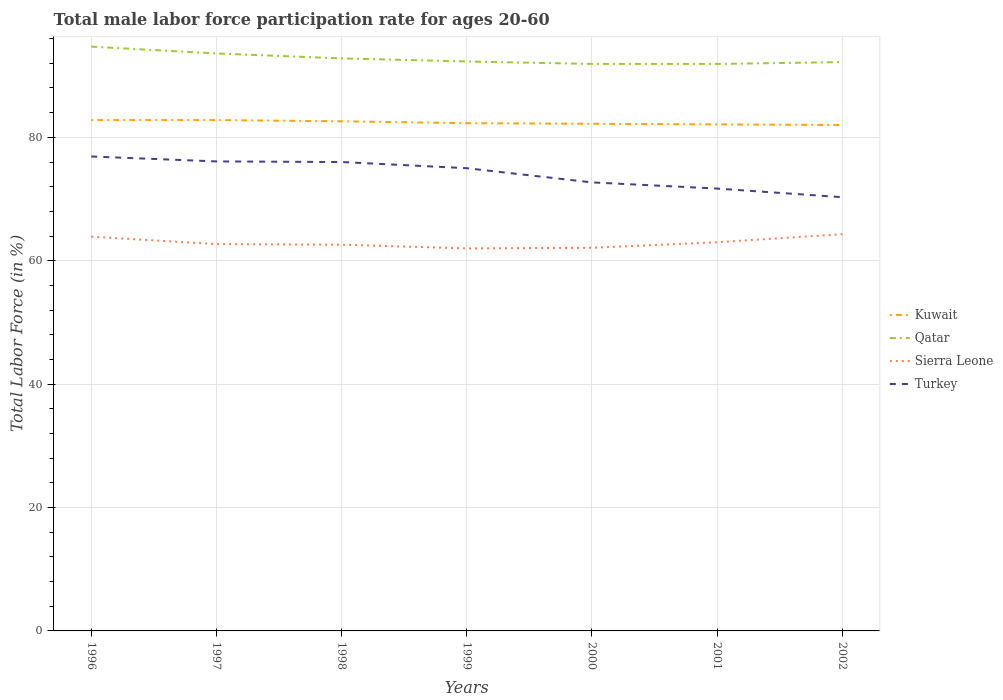How many different coloured lines are there?
Your answer should be compact. 4. Does the line corresponding to Sierra Leone intersect with the line corresponding to Turkey?
Provide a short and direct response. No. Across all years, what is the maximum male labor force participation rate in Turkey?
Your answer should be compact. 70.3. In which year was the male labor force participation rate in Qatar maximum?
Provide a short and direct response. 2000. What is the total male labor force participation rate in Turkey in the graph?
Keep it short and to the point. 4.4. What is the difference between the highest and the second highest male labor force participation rate in Sierra Leone?
Provide a short and direct response. 2.3. How many lines are there?
Your response must be concise. 4. Are the values on the major ticks of Y-axis written in scientific E-notation?
Provide a succinct answer. No. Does the graph contain any zero values?
Provide a short and direct response. No. Where does the legend appear in the graph?
Your answer should be very brief. Center right. How many legend labels are there?
Give a very brief answer. 4. What is the title of the graph?
Ensure brevity in your answer.  Total male labor force participation rate for ages 20-60. Does "Tajikistan" appear as one of the legend labels in the graph?
Your answer should be very brief. No. What is the label or title of the X-axis?
Your answer should be very brief. Years. What is the label or title of the Y-axis?
Provide a short and direct response. Total Labor Force (in %). What is the Total Labor Force (in %) in Kuwait in 1996?
Give a very brief answer. 82.8. What is the Total Labor Force (in %) in Qatar in 1996?
Make the answer very short. 94.7. What is the Total Labor Force (in %) of Sierra Leone in 1996?
Ensure brevity in your answer.  63.9. What is the Total Labor Force (in %) of Turkey in 1996?
Keep it short and to the point. 76.9. What is the Total Labor Force (in %) of Kuwait in 1997?
Ensure brevity in your answer.  82.8. What is the Total Labor Force (in %) of Qatar in 1997?
Keep it short and to the point. 93.6. What is the Total Labor Force (in %) of Sierra Leone in 1997?
Provide a short and direct response. 62.7. What is the Total Labor Force (in %) in Turkey in 1997?
Your answer should be compact. 76.1. What is the Total Labor Force (in %) in Kuwait in 1998?
Keep it short and to the point. 82.6. What is the Total Labor Force (in %) in Qatar in 1998?
Provide a succinct answer. 92.8. What is the Total Labor Force (in %) of Sierra Leone in 1998?
Your answer should be very brief. 62.6. What is the Total Labor Force (in %) in Kuwait in 1999?
Provide a short and direct response. 82.3. What is the Total Labor Force (in %) of Qatar in 1999?
Your answer should be very brief. 92.3. What is the Total Labor Force (in %) in Kuwait in 2000?
Your answer should be very brief. 82.2. What is the Total Labor Force (in %) of Qatar in 2000?
Offer a terse response. 91.9. What is the Total Labor Force (in %) in Sierra Leone in 2000?
Keep it short and to the point. 62.1. What is the Total Labor Force (in %) of Turkey in 2000?
Ensure brevity in your answer.  72.7. What is the Total Labor Force (in %) in Kuwait in 2001?
Ensure brevity in your answer.  82.1. What is the Total Labor Force (in %) of Qatar in 2001?
Give a very brief answer. 91.9. What is the Total Labor Force (in %) in Turkey in 2001?
Provide a short and direct response. 71.7. What is the Total Labor Force (in %) of Qatar in 2002?
Offer a terse response. 92.2. What is the Total Labor Force (in %) in Sierra Leone in 2002?
Give a very brief answer. 64.3. What is the Total Labor Force (in %) in Turkey in 2002?
Your answer should be compact. 70.3. Across all years, what is the maximum Total Labor Force (in %) of Kuwait?
Give a very brief answer. 82.8. Across all years, what is the maximum Total Labor Force (in %) in Qatar?
Offer a terse response. 94.7. Across all years, what is the maximum Total Labor Force (in %) in Sierra Leone?
Your answer should be very brief. 64.3. Across all years, what is the maximum Total Labor Force (in %) in Turkey?
Offer a very short reply. 76.9. Across all years, what is the minimum Total Labor Force (in %) in Qatar?
Make the answer very short. 91.9. Across all years, what is the minimum Total Labor Force (in %) in Sierra Leone?
Provide a succinct answer. 62. Across all years, what is the minimum Total Labor Force (in %) of Turkey?
Offer a very short reply. 70.3. What is the total Total Labor Force (in %) in Kuwait in the graph?
Give a very brief answer. 576.8. What is the total Total Labor Force (in %) in Qatar in the graph?
Provide a succinct answer. 649.4. What is the total Total Labor Force (in %) in Sierra Leone in the graph?
Ensure brevity in your answer.  440.6. What is the total Total Labor Force (in %) in Turkey in the graph?
Your answer should be very brief. 518.7. What is the difference between the Total Labor Force (in %) of Kuwait in 1996 and that in 1997?
Your answer should be compact. 0. What is the difference between the Total Labor Force (in %) in Kuwait in 1996 and that in 1998?
Make the answer very short. 0.2. What is the difference between the Total Labor Force (in %) in Sierra Leone in 1996 and that in 1998?
Keep it short and to the point. 1.3. What is the difference between the Total Labor Force (in %) in Kuwait in 1996 and that in 1999?
Your answer should be very brief. 0.5. What is the difference between the Total Labor Force (in %) of Sierra Leone in 1996 and that in 1999?
Offer a terse response. 1.9. What is the difference between the Total Labor Force (in %) of Kuwait in 1996 and that in 2000?
Keep it short and to the point. 0.6. What is the difference between the Total Labor Force (in %) in Qatar in 1996 and that in 2000?
Ensure brevity in your answer.  2.8. What is the difference between the Total Labor Force (in %) of Sierra Leone in 1996 and that in 2000?
Your response must be concise. 1.8. What is the difference between the Total Labor Force (in %) of Turkey in 1996 and that in 2000?
Offer a very short reply. 4.2. What is the difference between the Total Labor Force (in %) of Kuwait in 1996 and that in 2001?
Your answer should be compact. 0.7. What is the difference between the Total Labor Force (in %) in Qatar in 1996 and that in 2001?
Make the answer very short. 2.8. What is the difference between the Total Labor Force (in %) in Sierra Leone in 1996 and that in 2001?
Your answer should be compact. 0.9. What is the difference between the Total Labor Force (in %) of Turkey in 1996 and that in 2002?
Provide a short and direct response. 6.6. What is the difference between the Total Labor Force (in %) of Sierra Leone in 1997 and that in 1998?
Ensure brevity in your answer.  0.1. What is the difference between the Total Labor Force (in %) of Turkey in 1997 and that in 1998?
Offer a very short reply. 0.1. What is the difference between the Total Labor Force (in %) in Sierra Leone in 1997 and that in 1999?
Give a very brief answer. 0.7. What is the difference between the Total Labor Force (in %) of Turkey in 1997 and that in 1999?
Make the answer very short. 1.1. What is the difference between the Total Labor Force (in %) in Kuwait in 1997 and that in 2000?
Ensure brevity in your answer.  0.6. What is the difference between the Total Labor Force (in %) of Turkey in 1997 and that in 2000?
Give a very brief answer. 3.4. What is the difference between the Total Labor Force (in %) in Sierra Leone in 1997 and that in 2002?
Your answer should be very brief. -1.6. What is the difference between the Total Labor Force (in %) of Qatar in 1998 and that in 1999?
Your answer should be compact. 0.5. What is the difference between the Total Labor Force (in %) in Kuwait in 1998 and that in 2001?
Your answer should be very brief. 0.5. What is the difference between the Total Labor Force (in %) in Kuwait in 1998 and that in 2002?
Your answer should be compact. 0.6. What is the difference between the Total Labor Force (in %) in Sierra Leone in 1998 and that in 2002?
Ensure brevity in your answer.  -1.7. What is the difference between the Total Labor Force (in %) in Turkey in 1998 and that in 2002?
Ensure brevity in your answer.  5.7. What is the difference between the Total Labor Force (in %) of Kuwait in 1999 and that in 2000?
Offer a very short reply. 0.1. What is the difference between the Total Labor Force (in %) of Turkey in 1999 and that in 2000?
Provide a short and direct response. 2.3. What is the difference between the Total Labor Force (in %) in Kuwait in 1999 and that in 2001?
Offer a terse response. 0.2. What is the difference between the Total Labor Force (in %) of Qatar in 1999 and that in 2002?
Make the answer very short. 0.1. What is the difference between the Total Labor Force (in %) of Turkey in 1999 and that in 2002?
Ensure brevity in your answer.  4.7. What is the difference between the Total Labor Force (in %) in Turkey in 2000 and that in 2001?
Ensure brevity in your answer.  1. What is the difference between the Total Labor Force (in %) of Qatar in 2000 and that in 2002?
Your answer should be compact. -0.3. What is the difference between the Total Labor Force (in %) of Sierra Leone in 2000 and that in 2002?
Ensure brevity in your answer.  -2.2. What is the difference between the Total Labor Force (in %) in Qatar in 2001 and that in 2002?
Your answer should be very brief. -0.3. What is the difference between the Total Labor Force (in %) of Kuwait in 1996 and the Total Labor Force (in %) of Sierra Leone in 1997?
Make the answer very short. 20.1. What is the difference between the Total Labor Force (in %) in Qatar in 1996 and the Total Labor Force (in %) in Sierra Leone in 1997?
Offer a very short reply. 32. What is the difference between the Total Labor Force (in %) of Kuwait in 1996 and the Total Labor Force (in %) of Qatar in 1998?
Your answer should be compact. -10. What is the difference between the Total Labor Force (in %) in Kuwait in 1996 and the Total Labor Force (in %) in Sierra Leone in 1998?
Offer a very short reply. 20.2. What is the difference between the Total Labor Force (in %) of Kuwait in 1996 and the Total Labor Force (in %) of Turkey in 1998?
Your answer should be compact. 6.8. What is the difference between the Total Labor Force (in %) of Qatar in 1996 and the Total Labor Force (in %) of Sierra Leone in 1998?
Offer a terse response. 32.1. What is the difference between the Total Labor Force (in %) in Qatar in 1996 and the Total Labor Force (in %) in Turkey in 1998?
Offer a terse response. 18.7. What is the difference between the Total Labor Force (in %) of Sierra Leone in 1996 and the Total Labor Force (in %) of Turkey in 1998?
Ensure brevity in your answer.  -12.1. What is the difference between the Total Labor Force (in %) of Kuwait in 1996 and the Total Labor Force (in %) of Qatar in 1999?
Keep it short and to the point. -9.5. What is the difference between the Total Labor Force (in %) in Kuwait in 1996 and the Total Labor Force (in %) in Sierra Leone in 1999?
Provide a short and direct response. 20.8. What is the difference between the Total Labor Force (in %) of Kuwait in 1996 and the Total Labor Force (in %) of Turkey in 1999?
Your response must be concise. 7.8. What is the difference between the Total Labor Force (in %) of Qatar in 1996 and the Total Labor Force (in %) of Sierra Leone in 1999?
Keep it short and to the point. 32.7. What is the difference between the Total Labor Force (in %) of Qatar in 1996 and the Total Labor Force (in %) of Turkey in 1999?
Your answer should be very brief. 19.7. What is the difference between the Total Labor Force (in %) of Kuwait in 1996 and the Total Labor Force (in %) of Sierra Leone in 2000?
Offer a very short reply. 20.7. What is the difference between the Total Labor Force (in %) of Qatar in 1996 and the Total Labor Force (in %) of Sierra Leone in 2000?
Offer a very short reply. 32.6. What is the difference between the Total Labor Force (in %) in Sierra Leone in 1996 and the Total Labor Force (in %) in Turkey in 2000?
Your answer should be compact. -8.8. What is the difference between the Total Labor Force (in %) in Kuwait in 1996 and the Total Labor Force (in %) in Qatar in 2001?
Provide a short and direct response. -9.1. What is the difference between the Total Labor Force (in %) of Kuwait in 1996 and the Total Labor Force (in %) of Sierra Leone in 2001?
Your response must be concise. 19.8. What is the difference between the Total Labor Force (in %) in Kuwait in 1996 and the Total Labor Force (in %) in Turkey in 2001?
Your response must be concise. 11.1. What is the difference between the Total Labor Force (in %) of Qatar in 1996 and the Total Labor Force (in %) of Sierra Leone in 2001?
Your response must be concise. 31.7. What is the difference between the Total Labor Force (in %) in Kuwait in 1996 and the Total Labor Force (in %) in Qatar in 2002?
Offer a very short reply. -9.4. What is the difference between the Total Labor Force (in %) of Qatar in 1996 and the Total Labor Force (in %) of Sierra Leone in 2002?
Provide a short and direct response. 30.4. What is the difference between the Total Labor Force (in %) of Qatar in 1996 and the Total Labor Force (in %) of Turkey in 2002?
Make the answer very short. 24.4. What is the difference between the Total Labor Force (in %) in Kuwait in 1997 and the Total Labor Force (in %) in Qatar in 1998?
Ensure brevity in your answer.  -10. What is the difference between the Total Labor Force (in %) in Kuwait in 1997 and the Total Labor Force (in %) in Sierra Leone in 1998?
Make the answer very short. 20.2. What is the difference between the Total Labor Force (in %) in Kuwait in 1997 and the Total Labor Force (in %) in Qatar in 1999?
Ensure brevity in your answer.  -9.5. What is the difference between the Total Labor Force (in %) in Kuwait in 1997 and the Total Labor Force (in %) in Sierra Leone in 1999?
Give a very brief answer. 20.8. What is the difference between the Total Labor Force (in %) of Kuwait in 1997 and the Total Labor Force (in %) of Turkey in 1999?
Ensure brevity in your answer.  7.8. What is the difference between the Total Labor Force (in %) in Qatar in 1997 and the Total Labor Force (in %) in Sierra Leone in 1999?
Keep it short and to the point. 31.6. What is the difference between the Total Labor Force (in %) in Qatar in 1997 and the Total Labor Force (in %) in Turkey in 1999?
Keep it short and to the point. 18.6. What is the difference between the Total Labor Force (in %) of Sierra Leone in 1997 and the Total Labor Force (in %) of Turkey in 1999?
Keep it short and to the point. -12.3. What is the difference between the Total Labor Force (in %) in Kuwait in 1997 and the Total Labor Force (in %) in Sierra Leone in 2000?
Your response must be concise. 20.7. What is the difference between the Total Labor Force (in %) in Kuwait in 1997 and the Total Labor Force (in %) in Turkey in 2000?
Provide a short and direct response. 10.1. What is the difference between the Total Labor Force (in %) in Qatar in 1997 and the Total Labor Force (in %) in Sierra Leone in 2000?
Give a very brief answer. 31.5. What is the difference between the Total Labor Force (in %) in Qatar in 1997 and the Total Labor Force (in %) in Turkey in 2000?
Ensure brevity in your answer.  20.9. What is the difference between the Total Labor Force (in %) of Sierra Leone in 1997 and the Total Labor Force (in %) of Turkey in 2000?
Offer a very short reply. -10. What is the difference between the Total Labor Force (in %) of Kuwait in 1997 and the Total Labor Force (in %) of Sierra Leone in 2001?
Your response must be concise. 19.8. What is the difference between the Total Labor Force (in %) in Kuwait in 1997 and the Total Labor Force (in %) in Turkey in 2001?
Provide a short and direct response. 11.1. What is the difference between the Total Labor Force (in %) in Qatar in 1997 and the Total Labor Force (in %) in Sierra Leone in 2001?
Offer a terse response. 30.6. What is the difference between the Total Labor Force (in %) of Qatar in 1997 and the Total Labor Force (in %) of Turkey in 2001?
Make the answer very short. 21.9. What is the difference between the Total Labor Force (in %) of Kuwait in 1997 and the Total Labor Force (in %) of Sierra Leone in 2002?
Keep it short and to the point. 18.5. What is the difference between the Total Labor Force (in %) of Qatar in 1997 and the Total Labor Force (in %) of Sierra Leone in 2002?
Make the answer very short. 29.3. What is the difference between the Total Labor Force (in %) in Qatar in 1997 and the Total Labor Force (in %) in Turkey in 2002?
Give a very brief answer. 23.3. What is the difference between the Total Labor Force (in %) of Sierra Leone in 1997 and the Total Labor Force (in %) of Turkey in 2002?
Your answer should be very brief. -7.6. What is the difference between the Total Labor Force (in %) in Kuwait in 1998 and the Total Labor Force (in %) in Sierra Leone in 1999?
Make the answer very short. 20.6. What is the difference between the Total Labor Force (in %) of Kuwait in 1998 and the Total Labor Force (in %) of Turkey in 1999?
Provide a short and direct response. 7.6. What is the difference between the Total Labor Force (in %) of Qatar in 1998 and the Total Labor Force (in %) of Sierra Leone in 1999?
Offer a terse response. 30.8. What is the difference between the Total Labor Force (in %) of Qatar in 1998 and the Total Labor Force (in %) of Turkey in 1999?
Your response must be concise. 17.8. What is the difference between the Total Labor Force (in %) of Kuwait in 1998 and the Total Labor Force (in %) of Sierra Leone in 2000?
Offer a terse response. 20.5. What is the difference between the Total Labor Force (in %) in Kuwait in 1998 and the Total Labor Force (in %) in Turkey in 2000?
Give a very brief answer. 9.9. What is the difference between the Total Labor Force (in %) of Qatar in 1998 and the Total Labor Force (in %) of Sierra Leone in 2000?
Offer a terse response. 30.7. What is the difference between the Total Labor Force (in %) in Qatar in 1998 and the Total Labor Force (in %) in Turkey in 2000?
Keep it short and to the point. 20.1. What is the difference between the Total Labor Force (in %) of Sierra Leone in 1998 and the Total Labor Force (in %) of Turkey in 2000?
Offer a very short reply. -10.1. What is the difference between the Total Labor Force (in %) of Kuwait in 1998 and the Total Labor Force (in %) of Sierra Leone in 2001?
Offer a very short reply. 19.6. What is the difference between the Total Labor Force (in %) of Qatar in 1998 and the Total Labor Force (in %) of Sierra Leone in 2001?
Offer a very short reply. 29.8. What is the difference between the Total Labor Force (in %) in Qatar in 1998 and the Total Labor Force (in %) in Turkey in 2001?
Offer a very short reply. 21.1. What is the difference between the Total Labor Force (in %) of Kuwait in 1998 and the Total Labor Force (in %) of Qatar in 2002?
Keep it short and to the point. -9.6. What is the difference between the Total Labor Force (in %) of Kuwait in 1998 and the Total Labor Force (in %) of Turkey in 2002?
Offer a terse response. 12.3. What is the difference between the Total Labor Force (in %) of Qatar in 1998 and the Total Labor Force (in %) of Sierra Leone in 2002?
Ensure brevity in your answer.  28.5. What is the difference between the Total Labor Force (in %) of Qatar in 1998 and the Total Labor Force (in %) of Turkey in 2002?
Offer a terse response. 22.5. What is the difference between the Total Labor Force (in %) in Sierra Leone in 1998 and the Total Labor Force (in %) in Turkey in 2002?
Offer a very short reply. -7.7. What is the difference between the Total Labor Force (in %) of Kuwait in 1999 and the Total Labor Force (in %) of Qatar in 2000?
Make the answer very short. -9.6. What is the difference between the Total Labor Force (in %) in Kuwait in 1999 and the Total Labor Force (in %) in Sierra Leone in 2000?
Give a very brief answer. 20.2. What is the difference between the Total Labor Force (in %) of Qatar in 1999 and the Total Labor Force (in %) of Sierra Leone in 2000?
Your answer should be compact. 30.2. What is the difference between the Total Labor Force (in %) in Qatar in 1999 and the Total Labor Force (in %) in Turkey in 2000?
Ensure brevity in your answer.  19.6. What is the difference between the Total Labor Force (in %) of Kuwait in 1999 and the Total Labor Force (in %) of Sierra Leone in 2001?
Offer a very short reply. 19.3. What is the difference between the Total Labor Force (in %) in Qatar in 1999 and the Total Labor Force (in %) in Sierra Leone in 2001?
Provide a succinct answer. 29.3. What is the difference between the Total Labor Force (in %) in Qatar in 1999 and the Total Labor Force (in %) in Turkey in 2001?
Ensure brevity in your answer.  20.6. What is the difference between the Total Labor Force (in %) of Sierra Leone in 1999 and the Total Labor Force (in %) of Turkey in 2001?
Offer a very short reply. -9.7. What is the difference between the Total Labor Force (in %) in Kuwait in 1999 and the Total Labor Force (in %) in Qatar in 2002?
Your answer should be very brief. -9.9. What is the difference between the Total Labor Force (in %) of Kuwait in 1999 and the Total Labor Force (in %) of Sierra Leone in 2002?
Keep it short and to the point. 18. What is the difference between the Total Labor Force (in %) of Qatar in 1999 and the Total Labor Force (in %) of Sierra Leone in 2002?
Keep it short and to the point. 28. What is the difference between the Total Labor Force (in %) in Kuwait in 2000 and the Total Labor Force (in %) in Sierra Leone in 2001?
Keep it short and to the point. 19.2. What is the difference between the Total Labor Force (in %) of Kuwait in 2000 and the Total Labor Force (in %) of Turkey in 2001?
Keep it short and to the point. 10.5. What is the difference between the Total Labor Force (in %) in Qatar in 2000 and the Total Labor Force (in %) in Sierra Leone in 2001?
Keep it short and to the point. 28.9. What is the difference between the Total Labor Force (in %) of Qatar in 2000 and the Total Labor Force (in %) of Turkey in 2001?
Provide a short and direct response. 20.2. What is the difference between the Total Labor Force (in %) in Kuwait in 2000 and the Total Labor Force (in %) in Sierra Leone in 2002?
Your response must be concise. 17.9. What is the difference between the Total Labor Force (in %) in Kuwait in 2000 and the Total Labor Force (in %) in Turkey in 2002?
Your answer should be very brief. 11.9. What is the difference between the Total Labor Force (in %) in Qatar in 2000 and the Total Labor Force (in %) in Sierra Leone in 2002?
Your response must be concise. 27.6. What is the difference between the Total Labor Force (in %) of Qatar in 2000 and the Total Labor Force (in %) of Turkey in 2002?
Offer a very short reply. 21.6. What is the difference between the Total Labor Force (in %) in Sierra Leone in 2000 and the Total Labor Force (in %) in Turkey in 2002?
Provide a short and direct response. -8.2. What is the difference between the Total Labor Force (in %) of Kuwait in 2001 and the Total Labor Force (in %) of Qatar in 2002?
Offer a terse response. -10.1. What is the difference between the Total Labor Force (in %) of Qatar in 2001 and the Total Labor Force (in %) of Sierra Leone in 2002?
Your response must be concise. 27.6. What is the difference between the Total Labor Force (in %) in Qatar in 2001 and the Total Labor Force (in %) in Turkey in 2002?
Your answer should be compact. 21.6. What is the difference between the Total Labor Force (in %) of Sierra Leone in 2001 and the Total Labor Force (in %) of Turkey in 2002?
Make the answer very short. -7.3. What is the average Total Labor Force (in %) of Kuwait per year?
Make the answer very short. 82.4. What is the average Total Labor Force (in %) of Qatar per year?
Give a very brief answer. 92.77. What is the average Total Labor Force (in %) in Sierra Leone per year?
Provide a short and direct response. 62.94. What is the average Total Labor Force (in %) of Turkey per year?
Your response must be concise. 74.1. In the year 1996, what is the difference between the Total Labor Force (in %) of Kuwait and Total Labor Force (in %) of Sierra Leone?
Ensure brevity in your answer.  18.9. In the year 1996, what is the difference between the Total Labor Force (in %) in Qatar and Total Labor Force (in %) in Sierra Leone?
Provide a short and direct response. 30.8. In the year 1996, what is the difference between the Total Labor Force (in %) in Sierra Leone and Total Labor Force (in %) in Turkey?
Offer a terse response. -13. In the year 1997, what is the difference between the Total Labor Force (in %) in Kuwait and Total Labor Force (in %) in Qatar?
Provide a short and direct response. -10.8. In the year 1997, what is the difference between the Total Labor Force (in %) of Kuwait and Total Labor Force (in %) of Sierra Leone?
Make the answer very short. 20.1. In the year 1997, what is the difference between the Total Labor Force (in %) in Qatar and Total Labor Force (in %) in Sierra Leone?
Offer a terse response. 30.9. In the year 1997, what is the difference between the Total Labor Force (in %) in Qatar and Total Labor Force (in %) in Turkey?
Ensure brevity in your answer.  17.5. In the year 1997, what is the difference between the Total Labor Force (in %) of Sierra Leone and Total Labor Force (in %) of Turkey?
Provide a short and direct response. -13.4. In the year 1998, what is the difference between the Total Labor Force (in %) in Kuwait and Total Labor Force (in %) in Qatar?
Your answer should be compact. -10.2. In the year 1998, what is the difference between the Total Labor Force (in %) of Kuwait and Total Labor Force (in %) of Turkey?
Ensure brevity in your answer.  6.6. In the year 1998, what is the difference between the Total Labor Force (in %) of Qatar and Total Labor Force (in %) of Sierra Leone?
Ensure brevity in your answer.  30.2. In the year 1998, what is the difference between the Total Labor Force (in %) of Qatar and Total Labor Force (in %) of Turkey?
Give a very brief answer. 16.8. In the year 1998, what is the difference between the Total Labor Force (in %) in Sierra Leone and Total Labor Force (in %) in Turkey?
Your answer should be very brief. -13.4. In the year 1999, what is the difference between the Total Labor Force (in %) in Kuwait and Total Labor Force (in %) in Qatar?
Give a very brief answer. -10. In the year 1999, what is the difference between the Total Labor Force (in %) in Kuwait and Total Labor Force (in %) in Sierra Leone?
Make the answer very short. 20.3. In the year 1999, what is the difference between the Total Labor Force (in %) of Kuwait and Total Labor Force (in %) of Turkey?
Provide a short and direct response. 7.3. In the year 1999, what is the difference between the Total Labor Force (in %) of Qatar and Total Labor Force (in %) of Sierra Leone?
Give a very brief answer. 30.3. In the year 1999, what is the difference between the Total Labor Force (in %) of Qatar and Total Labor Force (in %) of Turkey?
Offer a very short reply. 17.3. In the year 1999, what is the difference between the Total Labor Force (in %) of Sierra Leone and Total Labor Force (in %) of Turkey?
Provide a succinct answer. -13. In the year 2000, what is the difference between the Total Labor Force (in %) in Kuwait and Total Labor Force (in %) in Qatar?
Your response must be concise. -9.7. In the year 2000, what is the difference between the Total Labor Force (in %) of Kuwait and Total Labor Force (in %) of Sierra Leone?
Your answer should be very brief. 20.1. In the year 2000, what is the difference between the Total Labor Force (in %) of Kuwait and Total Labor Force (in %) of Turkey?
Offer a terse response. 9.5. In the year 2000, what is the difference between the Total Labor Force (in %) of Qatar and Total Labor Force (in %) of Sierra Leone?
Offer a very short reply. 29.8. In the year 2000, what is the difference between the Total Labor Force (in %) in Qatar and Total Labor Force (in %) in Turkey?
Your answer should be compact. 19.2. In the year 2001, what is the difference between the Total Labor Force (in %) of Kuwait and Total Labor Force (in %) of Sierra Leone?
Make the answer very short. 19.1. In the year 2001, what is the difference between the Total Labor Force (in %) in Qatar and Total Labor Force (in %) in Sierra Leone?
Give a very brief answer. 28.9. In the year 2001, what is the difference between the Total Labor Force (in %) of Qatar and Total Labor Force (in %) of Turkey?
Your answer should be compact. 20.2. In the year 2001, what is the difference between the Total Labor Force (in %) in Sierra Leone and Total Labor Force (in %) in Turkey?
Make the answer very short. -8.7. In the year 2002, what is the difference between the Total Labor Force (in %) of Kuwait and Total Labor Force (in %) of Turkey?
Keep it short and to the point. 11.7. In the year 2002, what is the difference between the Total Labor Force (in %) in Qatar and Total Labor Force (in %) in Sierra Leone?
Your response must be concise. 27.9. In the year 2002, what is the difference between the Total Labor Force (in %) of Qatar and Total Labor Force (in %) of Turkey?
Offer a terse response. 21.9. In the year 2002, what is the difference between the Total Labor Force (in %) of Sierra Leone and Total Labor Force (in %) of Turkey?
Keep it short and to the point. -6. What is the ratio of the Total Labor Force (in %) in Kuwait in 1996 to that in 1997?
Make the answer very short. 1. What is the ratio of the Total Labor Force (in %) in Qatar in 1996 to that in 1997?
Ensure brevity in your answer.  1.01. What is the ratio of the Total Labor Force (in %) of Sierra Leone in 1996 to that in 1997?
Give a very brief answer. 1.02. What is the ratio of the Total Labor Force (in %) in Turkey in 1996 to that in 1997?
Ensure brevity in your answer.  1.01. What is the ratio of the Total Labor Force (in %) of Kuwait in 1996 to that in 1998?
Your answer should be compact. 1. What is the ratio of the Total Labor Force (in %) of Qatar in 1996 to that in 1998?
Your answer should be compact. 1.02. What is the ratio of the Total Labor Force (in %) of Sierra Leone in 1996 to that in 1998?
Give a very brief answer. 1.02. What is the ratio of the Total Labor Force (in %) of Turkey in 1996 to that in 1998?
Your answer should be compact. 1.01. What is the ratio of the Total Labor Force (in %) of Kuwait in 1996 to that in 1999?
Provide a short and direct response. 1.01. What is the ratio of the Total Labor Force (in %) of Sierra Leone in 1996 to that in 1999?
Ensure brevity in your answer.  1.03. What is the ratio of the Total Labor Force (in %) in Turkey in 1996 to that in 1999?
Your answer should be very brief. 1.03. What is the ratio of the Total Labor Force (in %) of Kuwait in 1996 to that in 2000?
Your answer should be very brief. 1.01. What is the ratio of the Total Labor Force (in %) in Qatar in 1996 to that in 2000?
Provide a succinct answer. 1.03. What is the ratio of the Total Labor Force (in %) of Sierra Leone in 1996 to that in 2000?
Give a very brief answer. 1.03. What is the ratio of the Total Labor Force (in %) in Turkey in 1996 to that in 2000?
Make the answer very short. 1.06. What is the ratio of the Total Labor Force (in %) of Kuwait in 1996 to that in 2001?
Offer a very short reply. 1.01. What is the ratio of the Total Labor Force (in %) in Qatar in 1996 to that in 2001?
Ensure brevity in your answer.  1.03. What is the ratio of the Total Labor Force (in %) in Sierra Leone in 1996 to that in 2001?
Provide a succinct answer. 1.01. What is the ratio of the Total Labor Force (in %) in Turkey in 1996 to that in 2001?
Your answer should be very brief. 1.07. What is the ratio of the Total Labor Force (in %) of Kuwait in 1996 to that in 2002?
Make the answer very short. 1.01. What is the ratio of the Total Labor Force (in %) in Qatar in 1996 to that in 2002?
Offer a very short reply. 1.03. What is the ratio of the Total Labor Force (in %) in Sierra Leone in 1996 to that in 2002?
Ensure brevity in your answer.  0.99. What is the ratio of the Total Labor Force (in %) in Turkey in 1996 to that in 2002?
Offer a very short reply. 1.09. What is the ratio of the Total Labor Force (in %) of Qatar in 1997 to that in 1998?
Give a very brief answer. 1.01. What is the ratio of the Total Labor Force (in %) in Kuwait in 1997 to that in 1999?
Offer a terse response. 1.01. What is the ratio of the Total Labor Force (in %) in Qatar in 1997 to that in 1999?
Ensure brevity in your answer.  1.01. What is the ratio of the Total Labor Force (in %) of Sierra Leone in 1997 to that in 1999?
Give a very brief answer. 1.01. What is the ratio of the Total Labor Force (in %) of Turkey in 1997 to that in 1999?
Your answer should be very brief. 1.01. What is the ratio of the Total Labor Force (in %) of Kuwait in 1997 to that in 2000?
Offer a terse response. 1.01. What is the ratio of the Total Labor Force (in %) of Qatar in 1997 to that in 2000?
Give a very brief answer. 1.02. What is the ratio of the Total Labor Force (in %) in Sierra Leone in 1997 to that in 2000?
Offer a terse response. 1.01. What is the ratio of the Total Labor Force (in %) in Turkey in 1997 to that in 2000?
Your answer should be compact. 1.05. What is the ratio of the Total Labor Force (in %) in Kuwait in 1997 to that in 2001?
Provide a short and direct response. 1.01. What is the ratio of the Total Labor Force (in %) in Qatar in 1997 to that in 2001?
Offer a very short reply. 1.02. What is the ratio of the Total Labor Force (in %) of Sierra Leone in 1997 to that in 2001?
Your answer should be very brief. 1. What is the ratio of the Total Labor Force (in %) in Turkey in 1997 to that in 2001?
Provide a succinct answer. 1.06. What is the ratio of the Total Labor Force (in %) of Kuwait in 1997 to that in 2002?
Make the answer very short. 1.01. What is the ratio of the Total Labor Force (in %) of Qatar in 1997 to that in 2002?
Provide a succinct answer. 1.02. What is the ratio of the Total Labor Force (in %) in Sierra Leone in 1997 to that in 2002?
Make the answer very short. 0.98. What is the ratio of the Total Labor Force (in %) in Turkey in 1997 to that in 2002?
Provide a short and direct response. 1.08. What is the ratio of the Total Labor Force (in %) of Kuwait in 1998 to that in 1999?
Provide a short and direct response. 1. What is the ratio of the Total Labor Force (in %) in Qatar in 1998 to that in 1999?
Make the answer very short. 1.01. What is the ratio of the Total Labor Force (in %) of Sierra Leone in 1998 to that in 1999?
Offer a very short reply. 1.01. What is the ratio of the Total Labor Force (in %) of Turkey in 1998 to that in 1999?
Give a very brief answer. 1.01. What is the ratio of the Total Labor Force (in %) in Kuwait in 1998 to that in 2000?
Offer a very short reply. 1. What is the ratio of the Total Labor Force (in %) of Qatar in 1998 to that in 2000?
Ensure brevity in your answer.  1.01. What is the ratio of the Total Labor Force (in %) in Sierra Leone in 1998 to that in 2000?
Your answer should be compact. 1.01. What is the ratio of the Total Labor Force (in %) in Turkey in 1998 to that in 2000?
Offer a very short reply. 1.05. What is the ratio of the Total Labor Force (in %) of Qatar in 1998 to that in 2001?
Your answer should be very brief. 1.01. What is the ratio of the Total Labor Force (in %) of Sierra Leone in 1998 to that in 2001?
Give a very brief answer. 0.99. What is the ratio of the Total Labor Force (in %) of Turkey in 1998 to that in 2001?
Your answer should be very brief. 1.06. What is the ratio of the Total Labor Force (in %) in Kuwait in 1998 to that in 2002?
Offer a very short reply. 1.01. What is the ratio of the Total Labor Force (in %) of Sierra Leone in 1998 to that in 2002?
Offer a very short reply. 0.97. What is the ratio of the Total Labor Force (in %) of Turkey in 1998 to that in 2002?
Your answer should be very brief. 1.08. What is the ratio of the Total Labor Force (in %) of Kuwait in 1999 to that in 2000?
Give a very brief answer. 1. What is the ratio of the Total Labor Force (in %) of Turkey in 1999 to that in 2000?
Your response must be concise. 1.03. What is the ratio of the Total Labor Force (in %) in Kuwait in 1999 to that in 2001?
Provide a succinct answer. 1. What is the ratio of the Total Labor Force (in %) in Sierra Leone in 1999 to that in 2001?
Keep it short and to the point. 0.98. What is the ratio of the Total Labor Force (in %) of Turkey in 1999 to that in 2001?
Offer a very short reply. 1.05. What is the ratio of the Total Labor Force (in %) of Sierra Leone in 1999 to that in 2002?
Keep it short and to the point. 0.96. What is the ratio of the Total Labor Force (in %) of Turkey in 1999 to that in 2002?
Provide a short and direct response. 1.07. What is the ratio of the Total Labor Force (in %) of Kuwait in 2000 to that in 2001?
Keep it short and to the point. 1. What is the ratio of the Total Labor Force (in %) in Sierra Leone in 2000 to that in 2001?
Your response must be concise. 0.99. What is the ratio of the Total Labor Force (in %) in Turkey in 2000 to that in 2001?
Give a very brief answer. 1.01. What is the ratio of the Total Labor Force (in %) in Kuwait in 2000 to that in 2002?
Your response must be concise. 1. What is the ratio of the Total Labor Force (in %) of Qatar in 2000 to that in 2002?
Make the answer very short. 1. What is the ratio of the Total Labor Force (in %) of Sierra Leone in 2000 to that in 2002?
Your answer should be compact. 0.97. What is the ratio of the Total Labor Force (in %) in Turkey in 2000 to that in 2002?
Make the answer very short. 1.03. What is the ratio of the Total Labor Force (in %) in Qatar in 2001 to that in 2002?
Ensure brevity in your answer.  1. What is the ratio of the Total Labor Force (in %) of Sierra Leone in 2001 to that in 2002?
Provide a succinct answer. 0.98. What is the ratio of the Total Labor Force (in %) in Turkey in 2001 to that in 2002?
Keep it short and to the point. 1.02. What is the difference between the highest and the second highest Total Labor Force (in %) of Kuwait?
Your answer should be compact. 0. What is the difference between the highest and the second highest Total Labor Force (in %) of Qatar?
Provide a short and direct response. 1.1. What is the difference between the highest and the second highest Total Labor Force (in %) in Sierra Leone?
Your answer should be compact. 0.4. What is the difference between the highest and the lowest Total Labor Force (in %) in Qatar?
Offer a terse response. 2.8. 